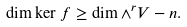<formula> <loc_0><loc_0><loc_500><loc_500>\dim \ker f \geq \dim \wedge ^ { r } V - n .</formula> 